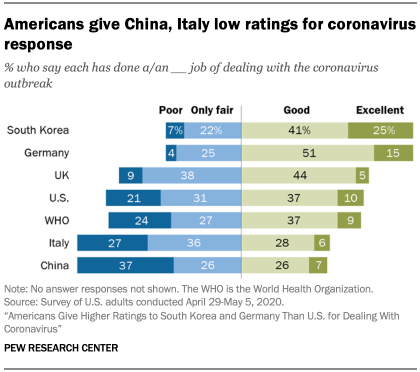Outline some significant characteristics in this image. The average of all the bars in Germany is not greater than the largest value of the green bar, indicating that the overall average height of Germany's bars is similar to the highest individual bar height. In South Korea, the value of the poor is 7%. 